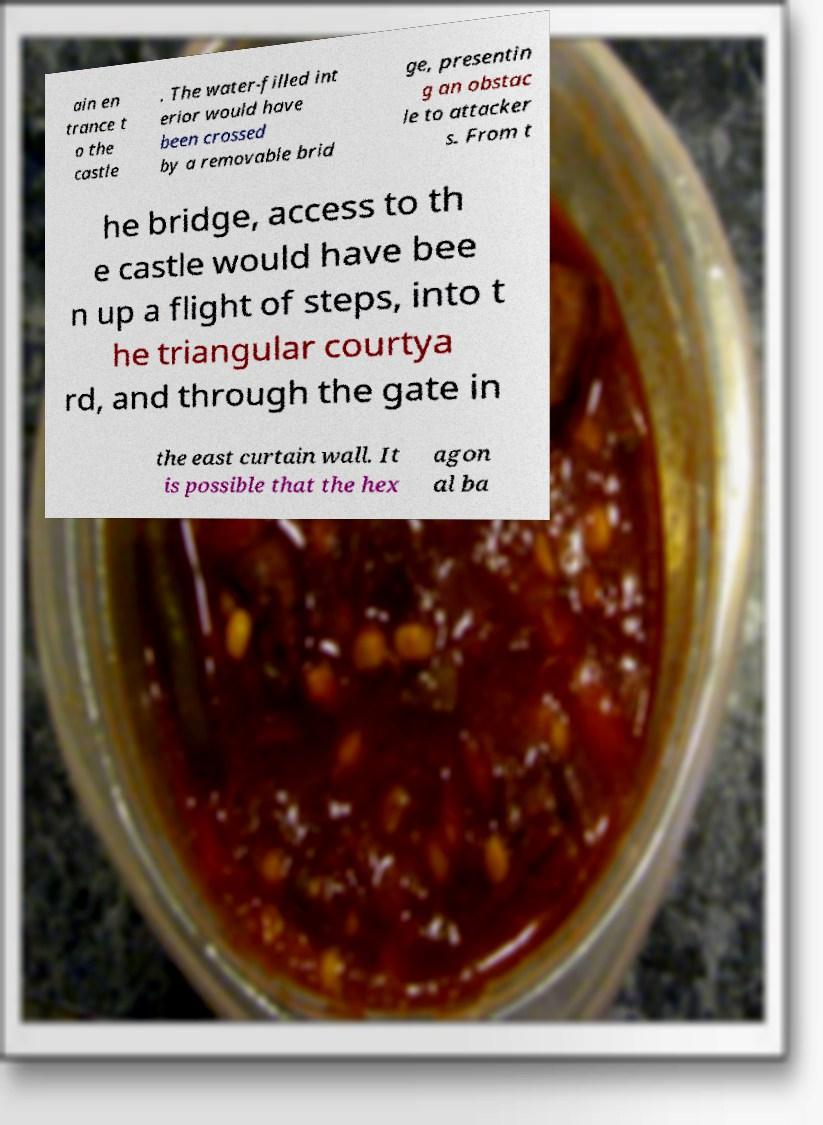What messages or text are displayed in this image? I need them in a readable, typed format. ain en trance t o the castle . The water-filled int erior would have been crossed by a removable brid ge, presentin g an obstac le to attacker s. From t he bridge, access to th e castle would have bee n up a flight of steps, into t he triangular courtya rd, and through the gate in the east curtain wall. It is possible that the hex agon al ba 